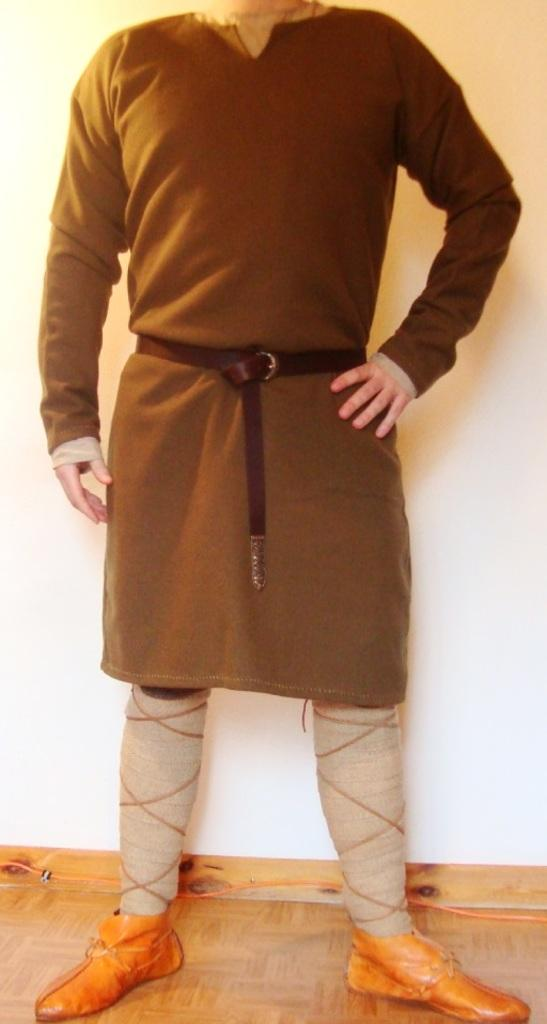What is the primary subject in the image? There is a person standing in the image. What type of surface is the person standing on? The person is standing on a wooden floor. What can be seen in the background of the image? There is a wall in the background of the image. Are there any other objects or features visible in the image? Yes, there is a wire in the image. What direction is the person facing in the image? The provided facts do not specify the direction the person is facing. How many dogs are present in the image? There are no dogs present in the image. What type of loaf is being used as a prop in the image? There is no loaf present in the image. 